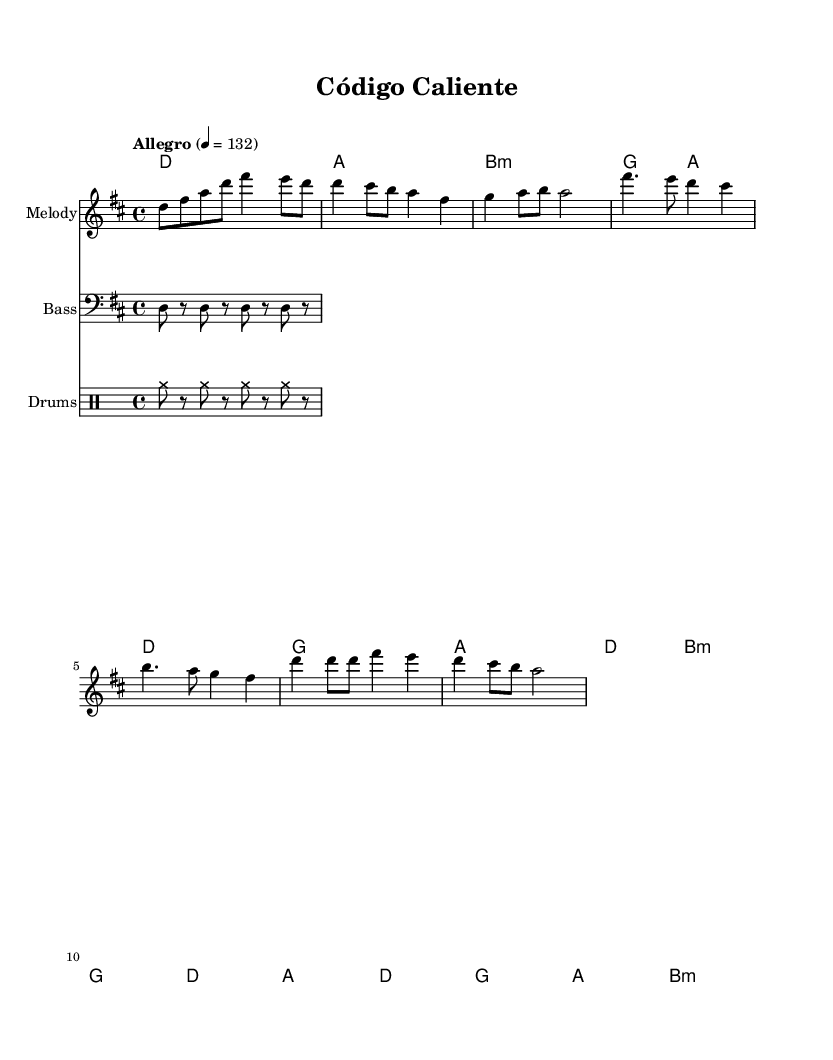What is the key signature of this music? The key signature indicated in the global section is D major, which has two sharps: F# and C#.
Answer: D major What is the time signature of this music? The time signature shown is 4/4, which means there are four beats in a measure and the quarter note gets one beat.
Answer: 4/4 What is the tempo marking for this piece? The tempo marking indicates "Allegro" with a metronome mark of quarter note = 132, meaning it should be played quickly at this pace.
Answer: Allegro, 132 How many measures are in the melody section? Counting the measures in the melody section shows there are a total of 8 measures, which correspond to the sections of the music including the intro, verse, pre-chorus, and chorus.
Answer: 8 What chord is played during the chorus? The chorus features the chords D, G, A, and B minor, indicated in the harmony section for that part of the song.
Answer: D, G, A, B minor What is the role of the bass part in this piece? The bass part primarily plays the root notes of the chords with a steady rhythm, providing harmonic foundation and groove to the piece.
Answer: Root notes What percussion instrument is indicated in the score? The percussion part includes the use of cymbals, shown in the drummode section with the cymr notation for rhythms.
Answer: Cymbals 